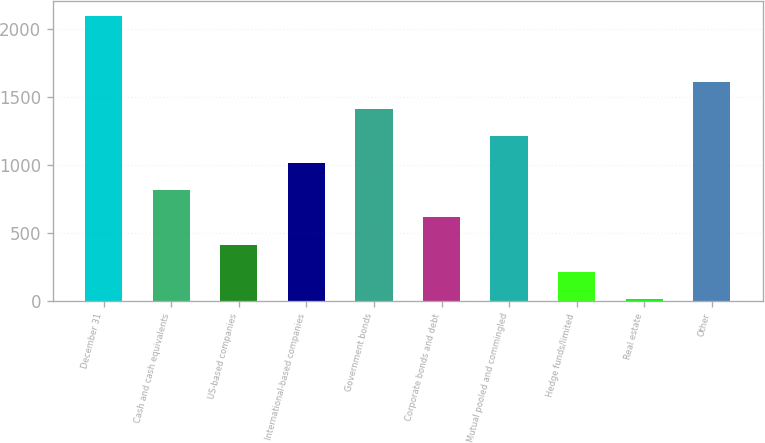Convert chart. <chart><loc_0><loc_0><loc_500><loc_500><bar_chart><fcel>December 31<fcel>Cash and cash equivalents<fcel>US-based companies<fcel>International-based companies<fcel>Government bonds<fcel>Corporate bonds and debt<fcel>Mutual pooled and commingled<fcel>Hedge funds/limited<fcel>Real estate<fcel>Other<nl><fcel>2096.7<fcel>812.8<fcel>413.4<fcel>1012.5<fcel>1411.9<fcel>613.1<fcel>1212.2<fcel>213.7<fcel>14<fcel>1611.6<nl></chart> 